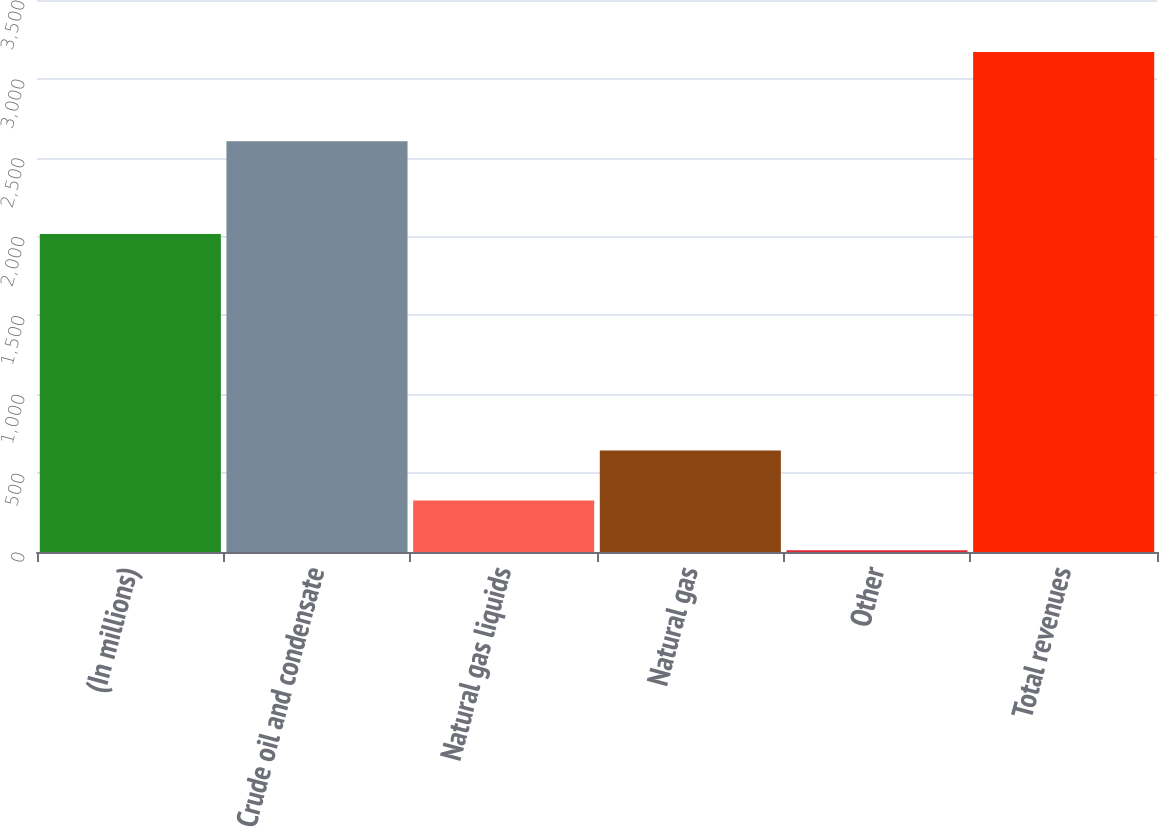Convert chart. <chart><loc_0><loc_0><loc_500><loc_500><bar_chart><fcel>(In millions)<fcel>Crude oil and condensate<fcel>Natural gas liquids<fcel>Natural gas<fcel>Other<fcel>Total revenues<nl><fcel>2016<fcel>2605<fcel>326.9<fcel>642.8<fcel>11<fcel>3170<nl></chart> 